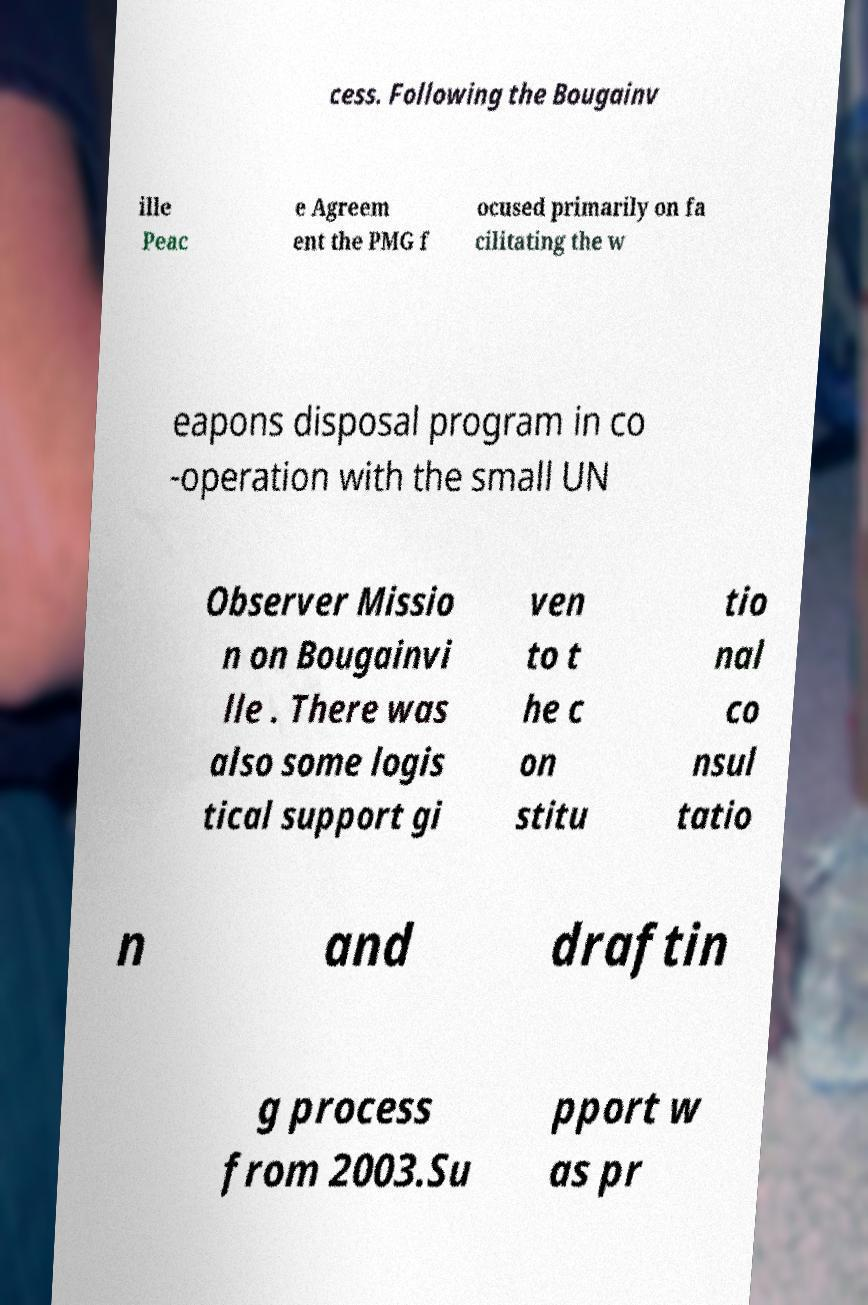Could you assist in decoding the text presented in this image and type it out clearly? cess. Following the Bougainv ille Peac e Agreem ent the PMG f ocused primarily on fa cilitating the w eapons disposal program in co -operation with the small UN Observer Missio n on Bougainvi lle . There was also some logis tical support gi ven to t he c on stitu tio nal co nsul tatio n and draftin g process from 2003.Su pport w as pr 